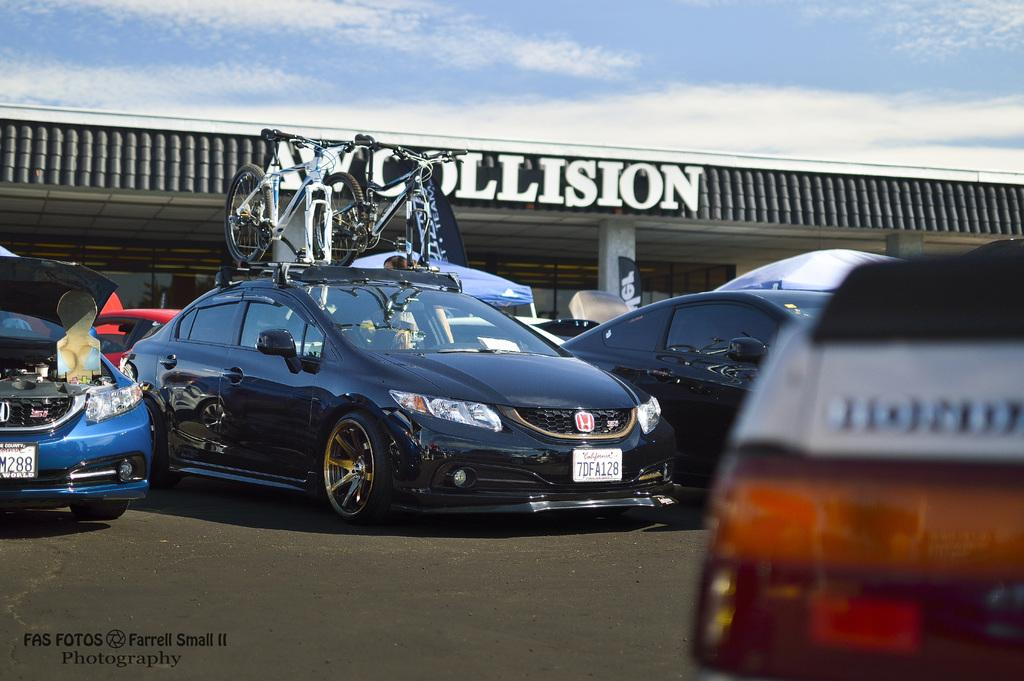<image>
Present a compact description of the photo's key features. Cars are parked in a lot in front of the AW Collision building. 